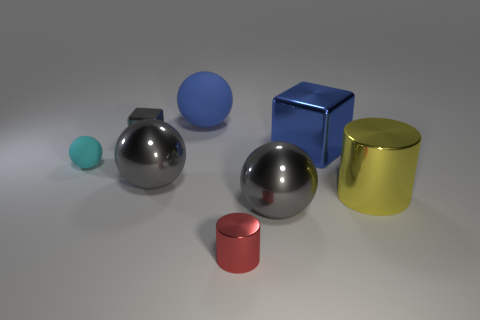Subtract all small balls. How many balls are left? 3 Subtract all brown cylinders. How many gray balls are left? 2 Subtract all blue spheres. How many spheres are left? 3 Add 1 gray metal balls. How many objects exist? 9 Subtract all cylinders. How many objects are left? 6 Subtract all brown spheres. Subtract all brown cylinders. How many spheres are left? 4 Subtract all large objects. Subtract all small red cylinders. How many objects are left? 2 Add 6 small red things. How many small red things are left? 7 Add 5 large metallic blocks. How many large metallic blocks exist? 6 Subtract 0 cyan cubes. How many objects are left? 8 